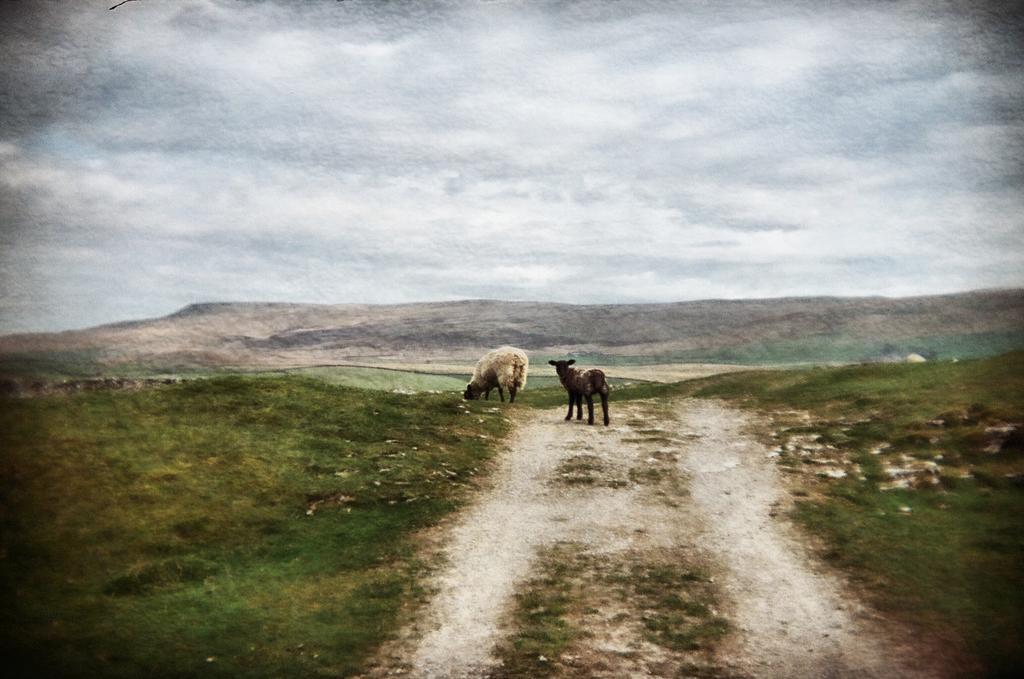In one or two sentences, can you explain what this image depicts? In this picture I can see couple of sheep and I can see a sheep grazing grass and hill and a cloudy Sky. 